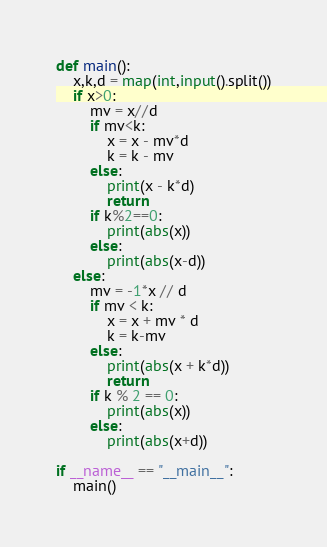<code> <loc_0><loc_0><loc_500><loc_500><_Python_>def main():
    x,k,d = map(int,input().split())
    if x>0:
        mv = x//d
        if mv<k:
            x = x - mv*d
            k = k - mv
        else:
            print(x - k*d)
            return
        if k%2==0:
            print(abs(x))
        else:
            print(abs(x-d))
    else:
        mv = -1*x // d
        if mv < k:
            x = x + mv * d
            k = k-mv
        else:
            print(abs(x + k*d))
            return
        if k % 2 == 0:
            print(abs(x))
        else:
            print(abs(x+d))

if __name__ == "__main__":
    main()
</code> 